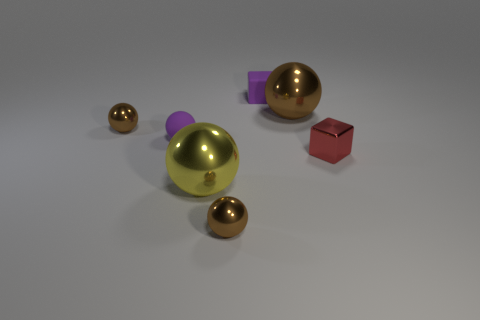The rubber cube that is the same color as the small rubber ball is what size?
Your answer should be compact. Small. What material is the small thing in front of the small red thing?
Provide a short and direct response. Metal. How many balls are the same color as the small rubber cube?
Provide a succinct answer. 1. What color is the tiny metallic sphere behind the tiny red metal cube?
Your answer should be very brief. Brown. What size is the other matte object that is the same shape as the red object?
Keep it short and to the point. Small. How many things are metallic objects in front of the large yellow metal thing or small shiny objects that are behind the small metal cube?
Ensure brevity in your answer.  2. What is the size of the thing that is right of the purple cube and left of the small red object?
Provide a short and direct response. Large. There is a red thing; is its shape the same as the tiny purple object behind the big brown shiny ball?
Offer a terse response. Yes. How many objects are small purple rubber objects to the right of the large yellow sphere or brown spheres?
Your response must be concise. 4. Is the tiny red object made of the same material as the purple object that is on the right side of the yellow shiny sphere?
Your answer should be very brief. No. 